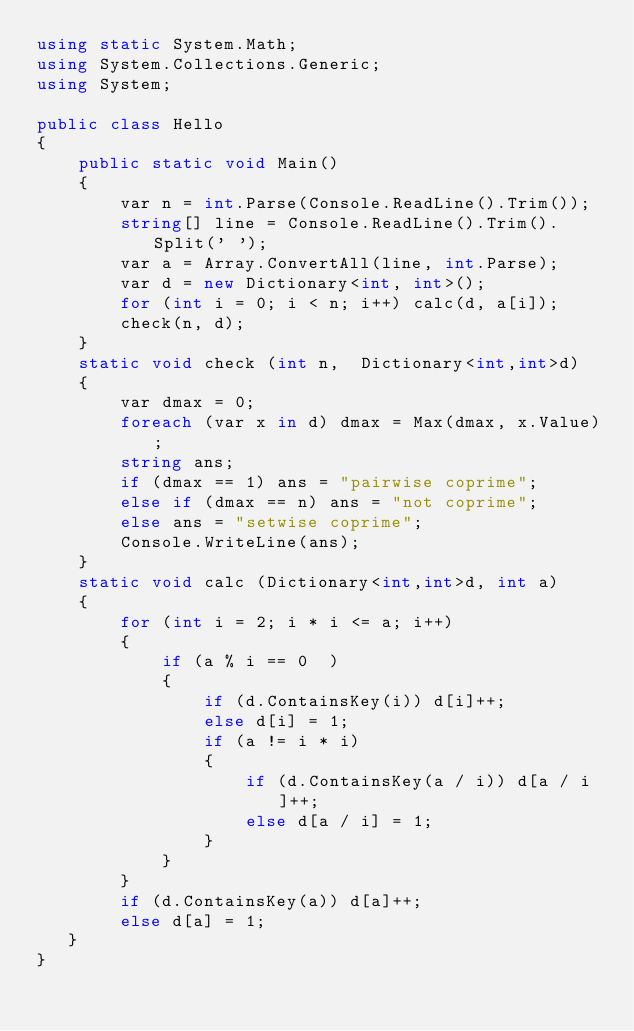Convert code to text. <code><loc_0><loc_0><loc_500><loc_500><_C#_>using static System.Math;
using System.Collections.Generic;
using System;

public class Hello
{
    public static void Main()
    {
        var n = int.Parse(Console.ReadLine().Trim());
        string[] line = Console.ReadLine().Trim().Split(' ');
        var a = Array.ConvertAll(line, int.Parse);
        var d = new Dictionary<int, int>();
        for (int i = 0; i < n; i++) calc(d, a[i]);
        check(n, d);
    }
    static void check (int n,  Dictionary<int,int>d)
    {
        var dmax = 0;
        foreach (var x in d) dmax = Max(dmax, x.Value);
        string ans;
        if (dmax == 1) ans = "pairwise coprime";
        else if (dmax == n) ans = "not coprime";
        else ans = "setwise coprime";
        Console.WriteLine(ans);
    }
    static void calc (Dictionary<int,int>d, int a)
    {
        for (int i = 2; i * i <= a; i++)
        {
            if (a % i == 0  )
            {
                if (d.ContainsKey(i)) d[i]++;
                else d[i] = 1;
                if (a != i * i)
                {
                    if (d.ContainsKey(a / i)) d[a / i]++;
                    else d[a / i] = 1;
                }
            }
        }
        if (d.ContainsKey(a)) d[a]++;
        else d[a] = 1;
   }
}
</code> 